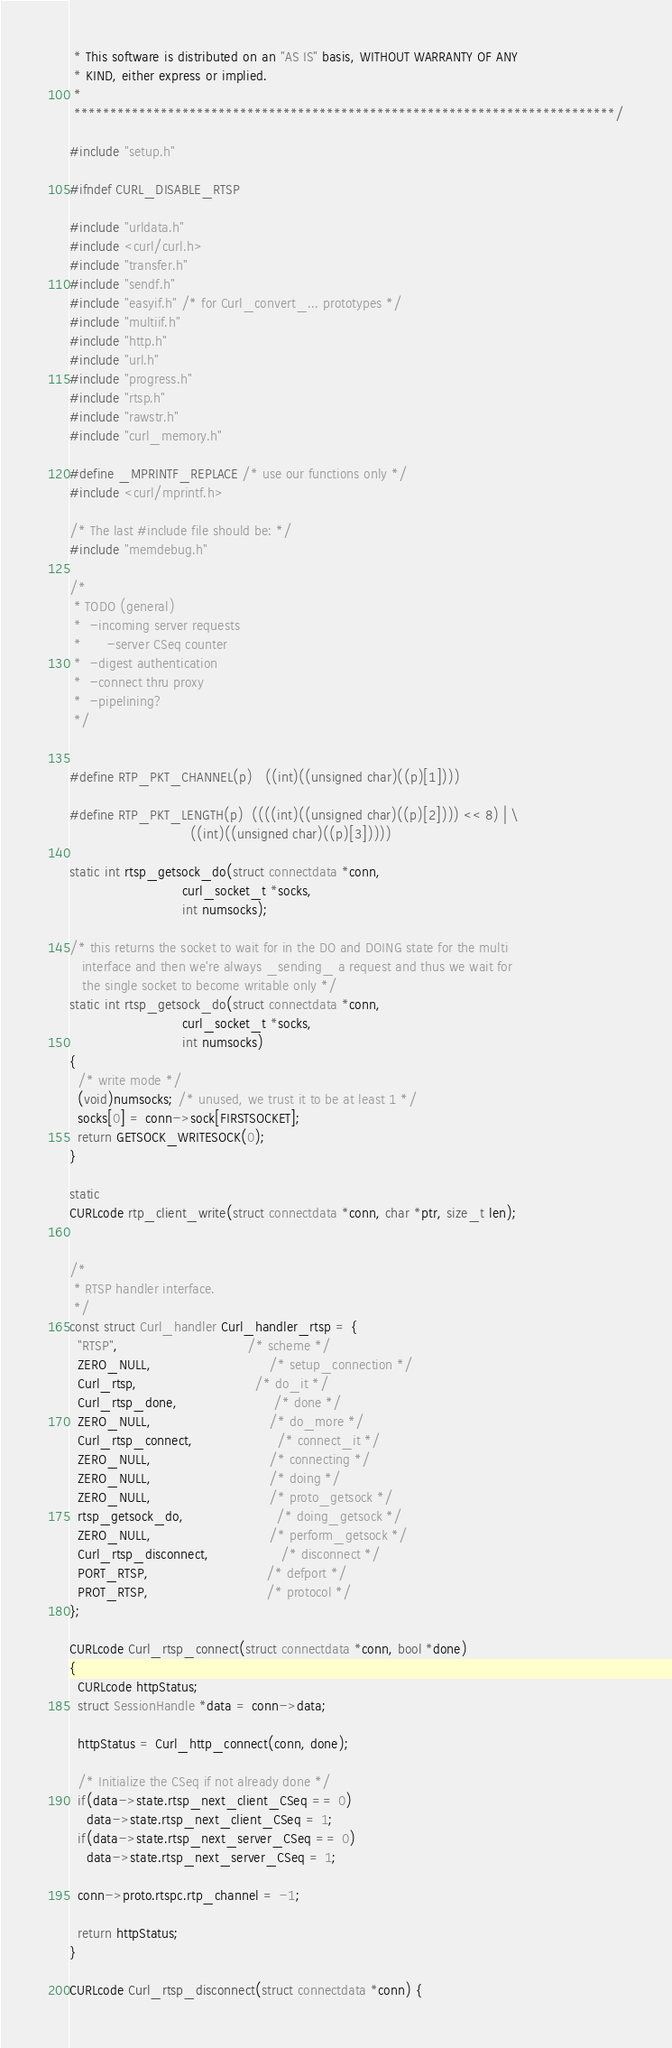<code> <loc_0><loc_0><loc_500><loc_500><_C_> * This software is distributed on an "AS IS" basis, WITHOUT WARRANTY OF ANY
 * KIND, either express or implied.
 *
 ***************************************************************************/

#include "setup.h"

#ifndef CURL_DISABLE_RTSP

#include "urldata.h"
#include <curl/curl.h>
#include "transfer.h"
#include "sendf.h"
#include "easyif.h" /* for Curl_convert_... prototypes */
#include "multiif.h"
#include "http.h"
#include "url.h"
#include "progress.h"
#include "rtsp.h"
#include "rawstr.h"
#include "curl_memory.h"

#define _MPRINTF_REPLACE /* use our functions only */
#include <curl/mprintf.h>

/* The last #include file should be: */
#include "memdebug.h"

/*
 * TODO (general)
 *  -incoming server requests
 *      -server CSeq counter
 *  -digest authentication
 *  -connect thru proxy
 *  -pipelining?
 */


#define RTP_PKT_CHANNEL(p)   ((int)((unsigned char)((p)[1])))

#define RTP_PKT_LENGTH(p)  ((((int)((unsigned char)((p)[2]))) << 8) | \
                             ((int)((unsigned char)((p)[3]))))

static int rtsp_getsock_do(struct connectdata *conn,
                           curl_socket_t *socks,
                           int numsocks);

/* this returns the socket to wait for in the DO and DOING state for the multi
   interface and then we're always _sending_ a request and thus we wait for
   the single socket to become writable only */
static int rtsp_getsock_do(struct connectdata *conn,
                           curl_socket_t *socks,
                           int numsocks)
{
  /* write mode */
  (void)numsocks; /* unused, we trust it to be at least 1 */
  socks[0] = conn->sock[FIRSTSOCKET];
  return GETSOCK_WRITESOCK(0);
}

static
CURLcode rtp_client_write(struct connectdata *conn, char *ptr, size_t len);


/*
 * RTSP handler interface.
 */
const struct Curl_handler Curl_handler_rtsp = {
  "RTSP",                               /* scheme */
  ZERO_NULL,                            /* setup_connection */
  Curl_rtsp,                            /* do_it */
  Curl_rtsp_done,                       /* done */
  ZERO_NULL,                            /* do_more */
  Curl_rtsp_connect,                    /* connect_it */
  ZERO_NULL,                            /* connecting */
  ZERO_NULL,                            /* doing */
  ZERO_NULL,                            /* proto_getsock */
  rtsp_getsock_do,                      /* doing_getsock */
  ZERO_NULL,                            /* perform_getsock */
  Curl_rtsp_disconnect,                 /* disconnect */
  PORT_RTSP,                            /* defport */
  PROT_RTSP,                            /* protocol */
};

CURLcode Curl_rtsp_connect(struct connectdata *conn, bool *done)
{
  CURLcode httpStatus;
  struct SessionHandle *data = conn->data;

  httpStatus = Curl_http_connect(conn, done);

  /* Initialize the CSeq if not already done */
  if(data->state.rtsp_next_client_CSeq == 0)
    data->state.rtsp_next_client_CSeq = 1;
  if(data->state.rtsp_next_server_CSeq == 0)
    data->state.rtsp_next_server_CSeq = 1;

  conn->proto.rtspc.rtp_channel = -1;

  return httpStatus;
}

CURLcode Curl_rtsp_disconnect(struct connectdata *conn) {</code> 